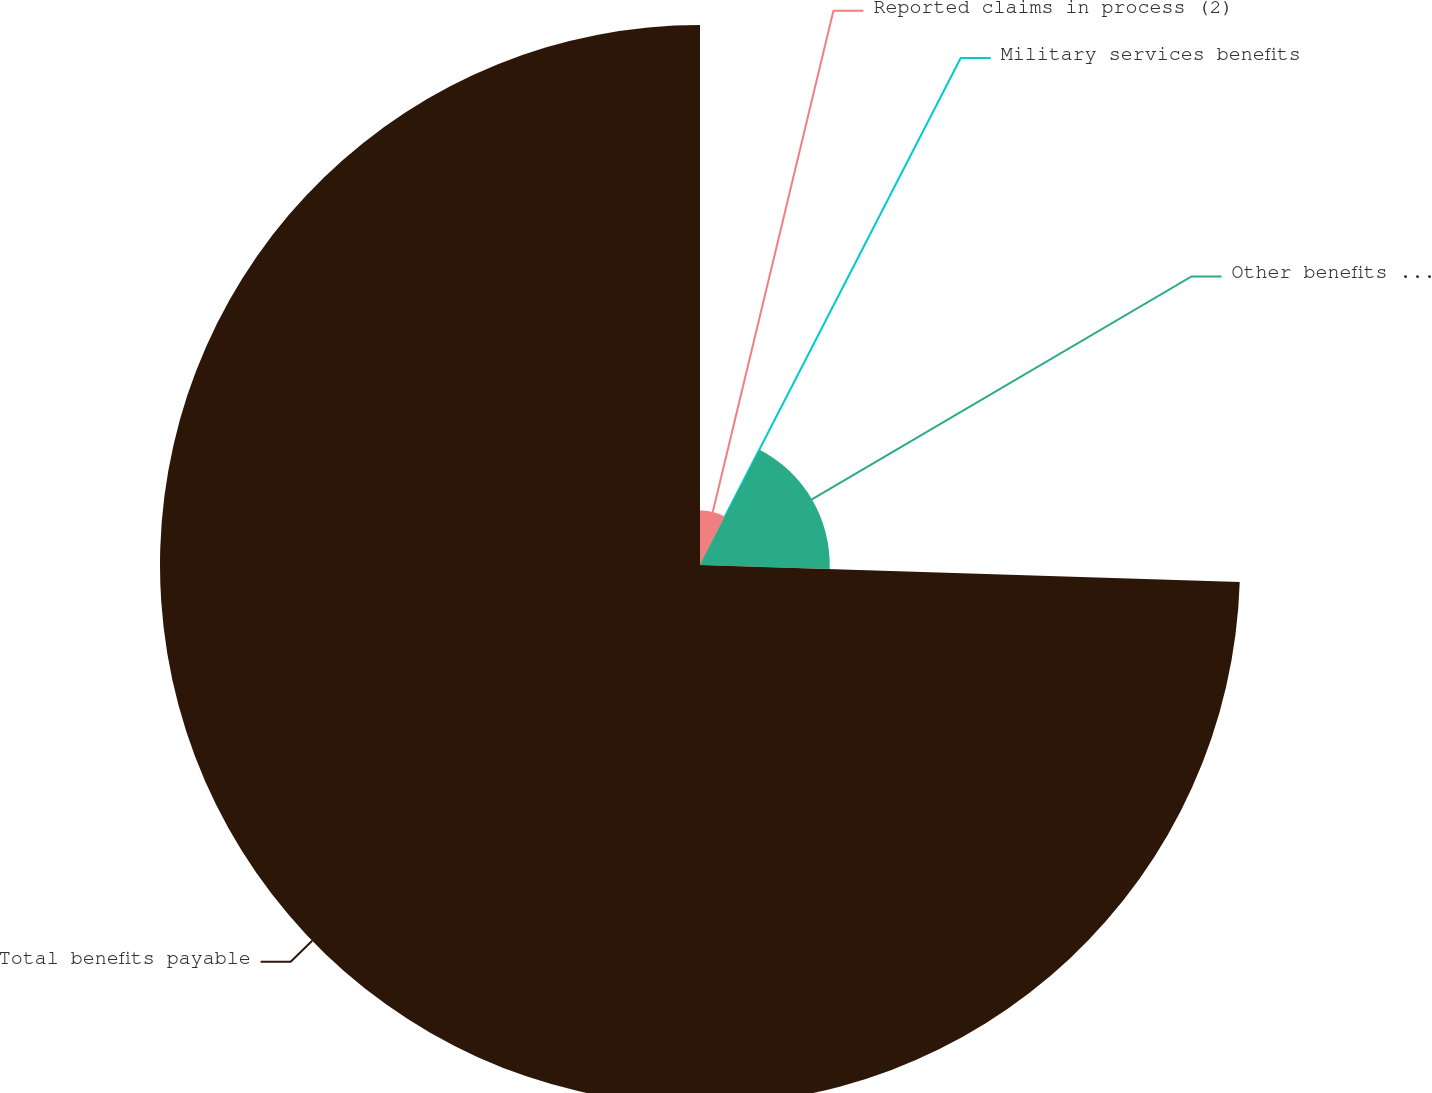Convert chart. <chart><loc_0><loc_0><loc_500><loc_500><pie_chart><fcel>Reported claims in process (2)<fcel>Military services benefits<fcel>Other benefits payable (4)<fcel>Total benefits payable<nl><fcel>7.52%<fcel>0.08%<fcel>17.9%<fcel>74.5%<nl></chart> 